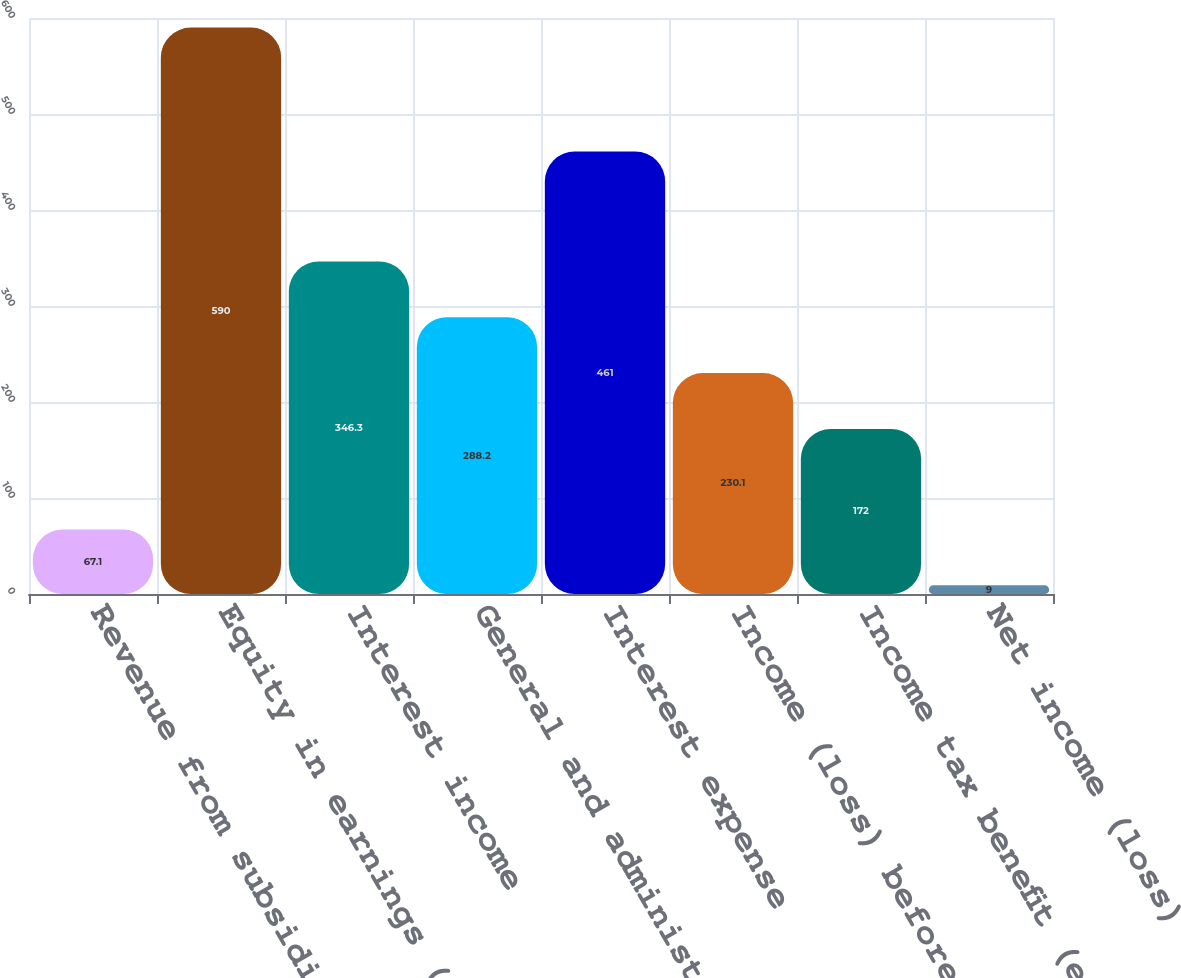Convert chart to OTSL. <chart><loc_0><loc_0><loc_500><loc_500><bar_chart><fcel>Revenue from subsidiaries and<fcel>Equity in earnings (loss) of<fcel>Interest income<fcel>General and administrative<fcel>Interest expense<fcel>Income (loss) before income<fcel>Income tax benefit (expense)<fcel>Net income (loss)<nl><fcel>67.1<fcel>590<fcel>346.3<fcel>288.2<fcel>461<fcel>230.1<fcel>172<fcel>9<nl></chart> 